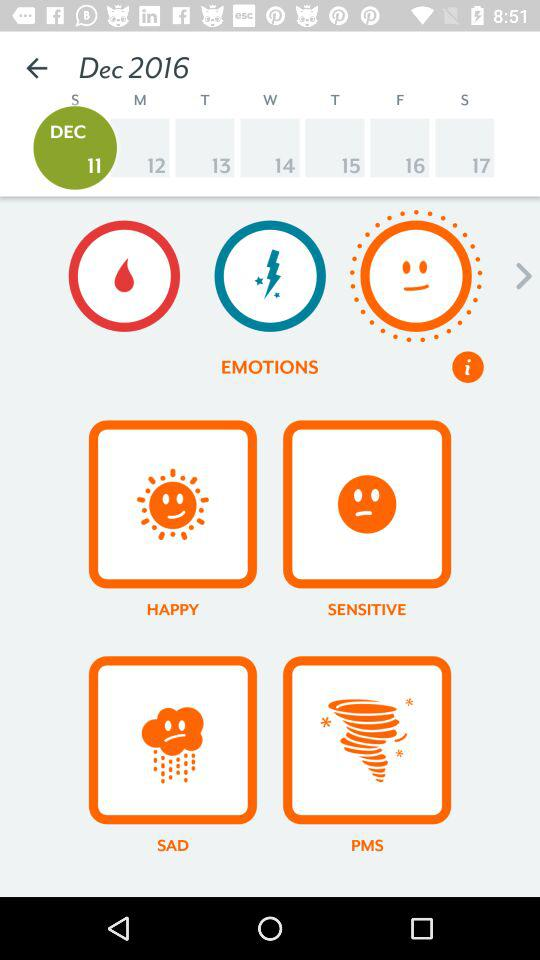What day is it on the selected date? The day is Sunday. 